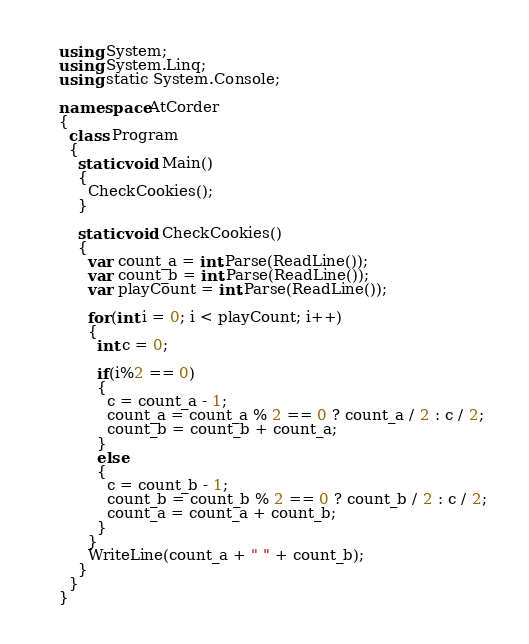Convert code to text. <code><loc_0><loc_0><loc_500><loc_500><_C#_>using System;
using System.Linq;
using static System.Console;

namespace AtCorder
{
  class Program
  {
    static void Main()
    {
      CheckCookies();
    }

    static void CheckCookies()
    {
      var count_a = int.Parse(ReadLine());
      var count_b = int.Parse(ReadLine());
      var playCount = int.Parse(ReadLine());

      for(int i = 0; i < playCount; i++)
      {
        int c = 0;

        if(i%2 == 0)
        {
          c = count_a - 1;
          count_a = count_a % 2 == 0 ? count_a / 2 : c / 2;
          count_b = count_b + count_a;
        } 
        else
        {
          c = count_b - 1;
          count_b = count_b % 2 == 0 ? count_b / 2 : c / 2;
          count_a = count_a + count_b;
        } 
      }
      WriteLine(count_a + " " + count_b);
    }
  }
}</code> 